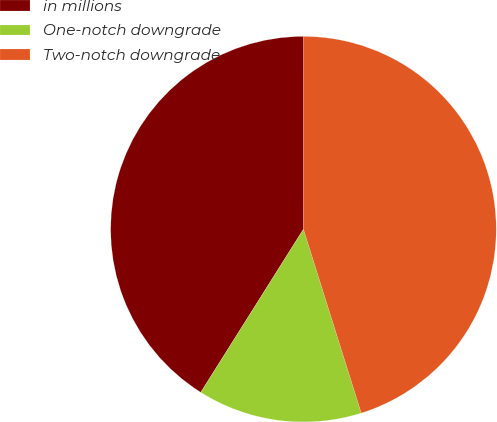Convert chart. <chart><loc_0><loc_0><loc_500><loc_500><pie_chart><fcel>in millions<fcel>One-notch downgrade<fcel>Two-notch downgrade<nl><fcel>41.07%<fcel>13.79%<fcel>45.14%<nl></chart> 